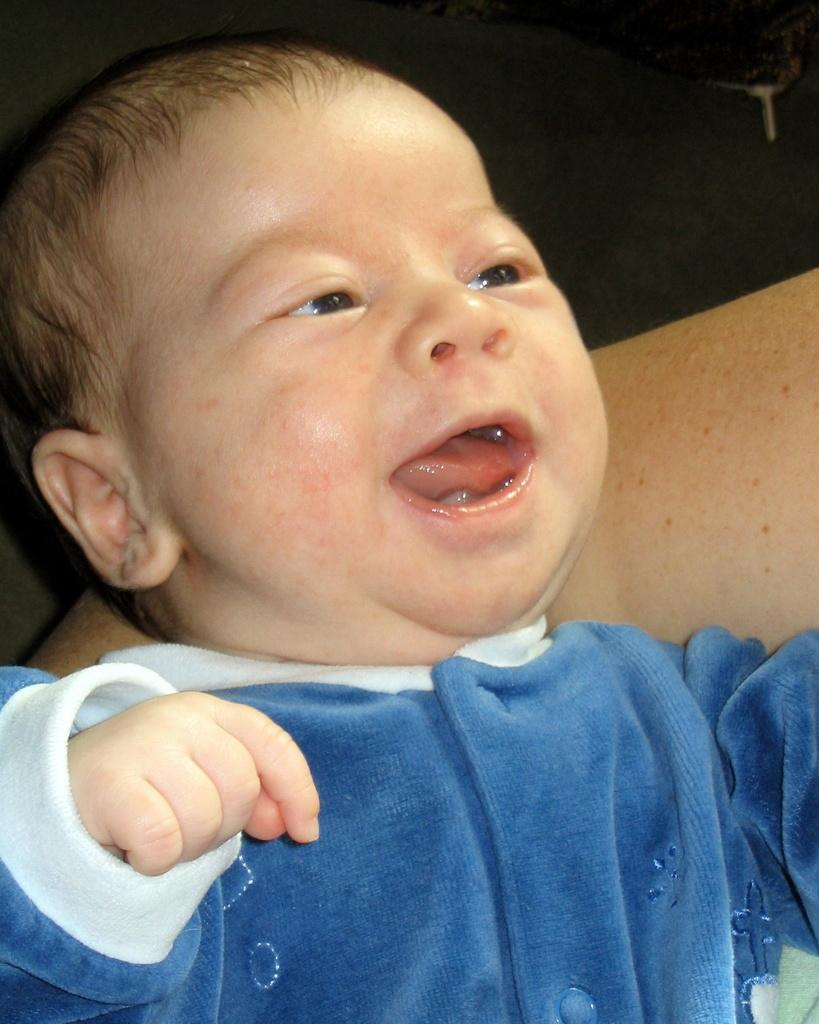Who is the main subject in the image? There is a boy in the image. What is the boy wearing? The boy is wearing a blue dress. Is there anyone else in the image besides the boy? Yes, there is a person holding the boy. What type of oven can be seen in the image? There is no oven present in the image. How many bites does the boy take out of the partner's hand in the image? There is no partner or biting action depicted in the image. 